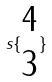Convert formula to latex. <formula><loc_0><loc_0><loc_500><loc_500>s \{ \begin{matrix} 4 \\ 3 \end{matrix} \}</formula> 